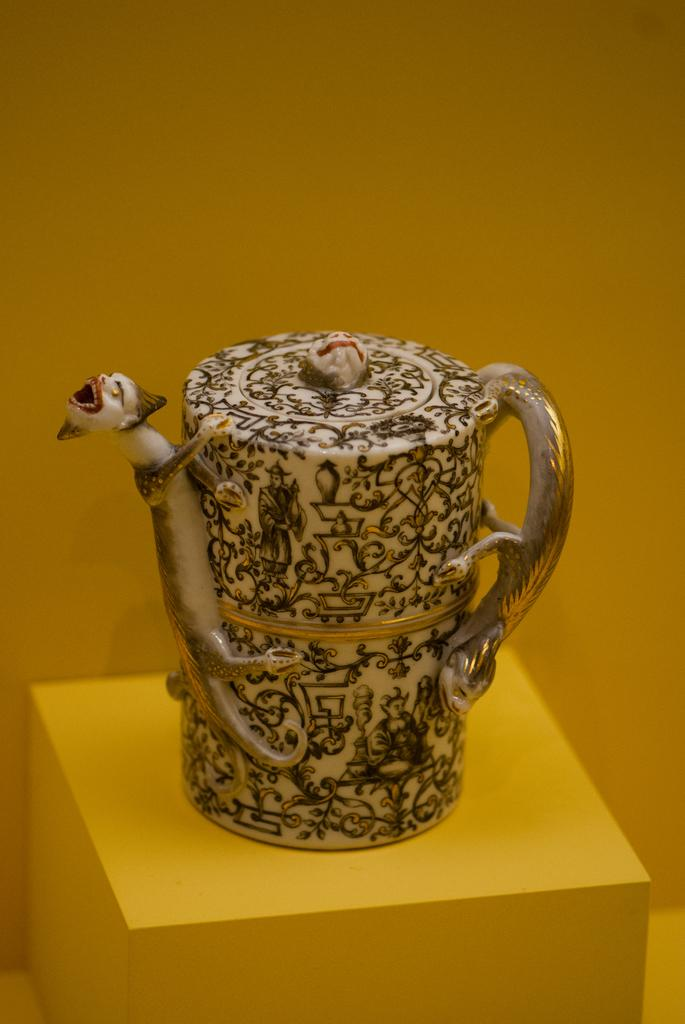What object is placed on a surface in the image? There is a jug placed on a surface in the image. What can be seen in the background of the image? There is a wall visible in the background of the image. How many cakes are on the island in the image? There is no island or cakes present in the image. What type of paper is being used to write on in the image? There is no paper or writing activity present in the image. 